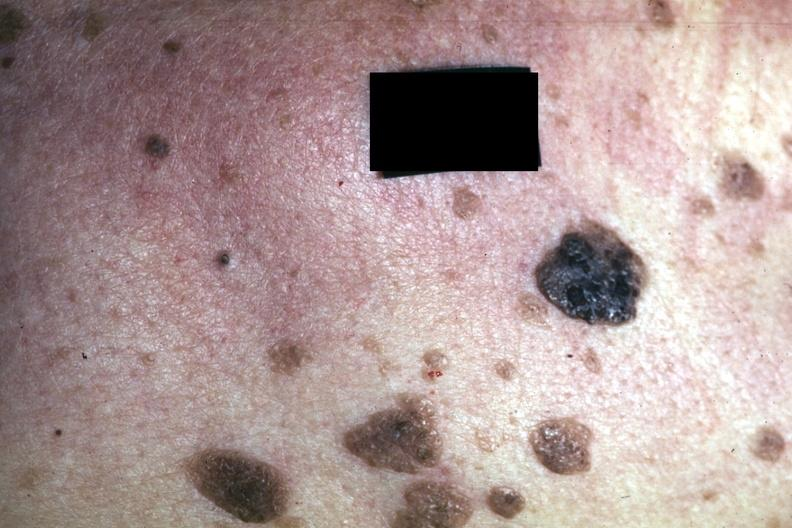s seborrheic keratosis present?
Answer the question using a single word or phrase. Yes 